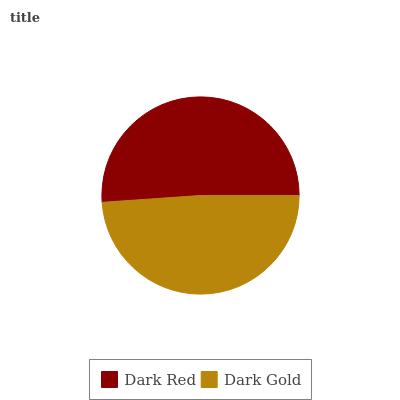Is Dark Gold the minimum?
Answer yes or no. Yes. Is Dark Red the maximum?
Answer yes or no. Yes. Is Dark Gold the maximum?
Answer yes or no. No. Is Dark Red greater than Dark Gold?
Answer yes or no. Yes. Is Dark Gold less than Dark Red?
Answer yes or no. Yes. Is Dark Gold greater than Dark Red?
Answer yes or no. No. Is Dark Red less than Dark Gold?
Answer yes or no. No. Is Dark Red the high median?
Answer yes or no. Yes. Is Dark Gold the low median?
Answer yes or no. Yes. Is Dark Gold the high median?
Answer yes or no. No. Is Dark Red the low median?
Answer yes or no. No. 